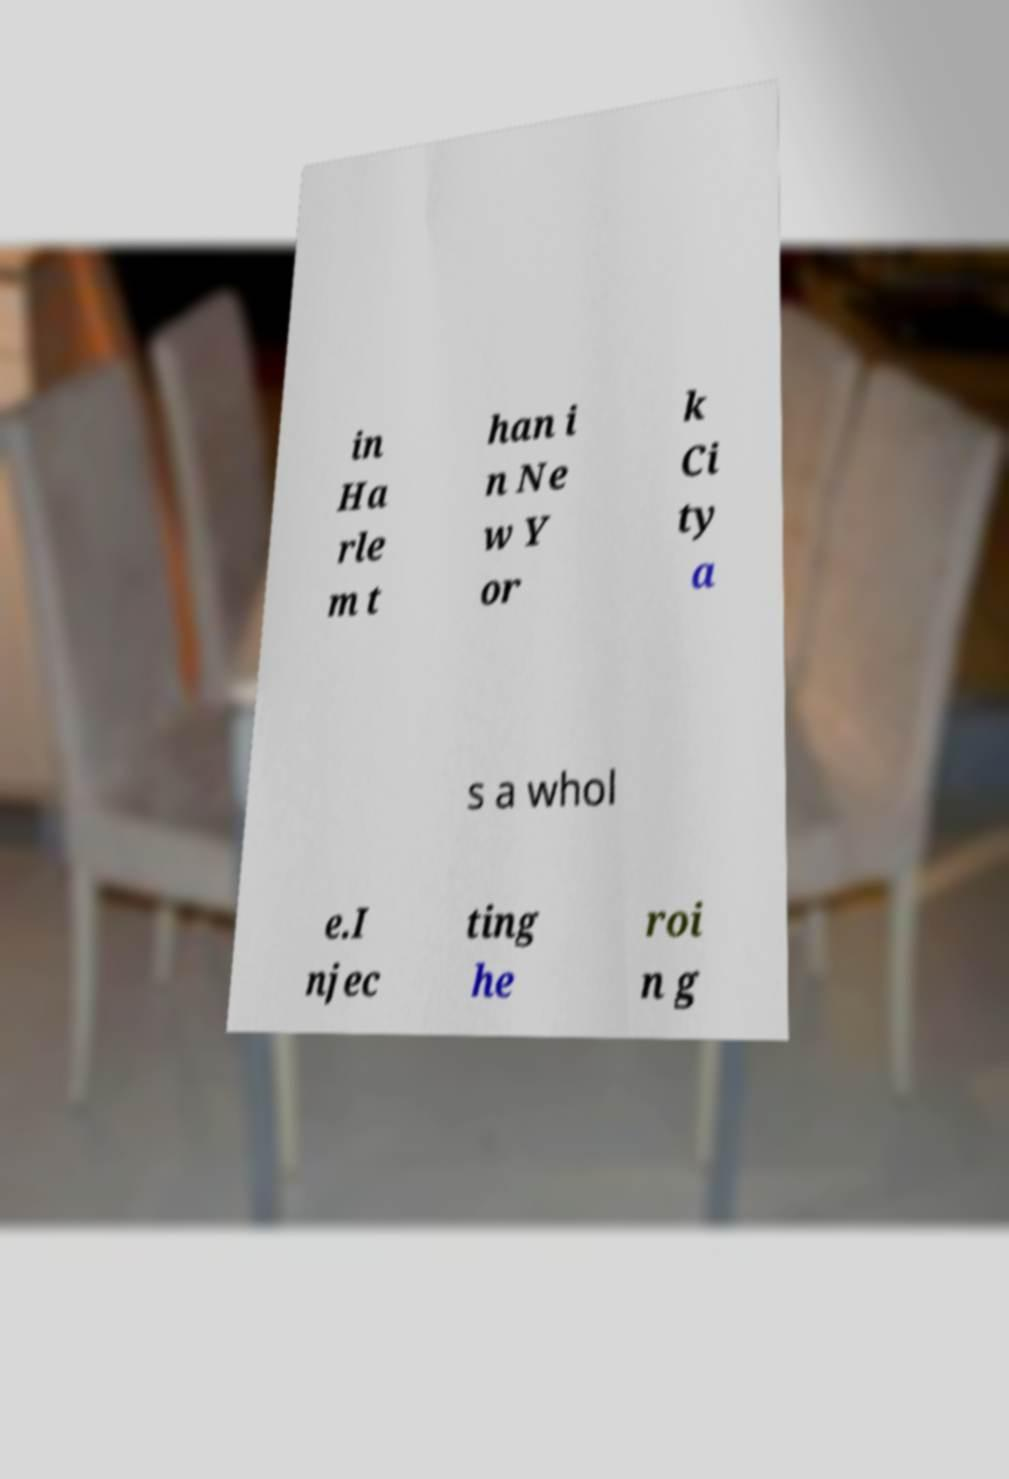Can you accurately transcribe the text from the provided image for me? in Ha rle m t han i n Ne w Y or k Ci ty a s a whol e.I njec ting he roi n g 